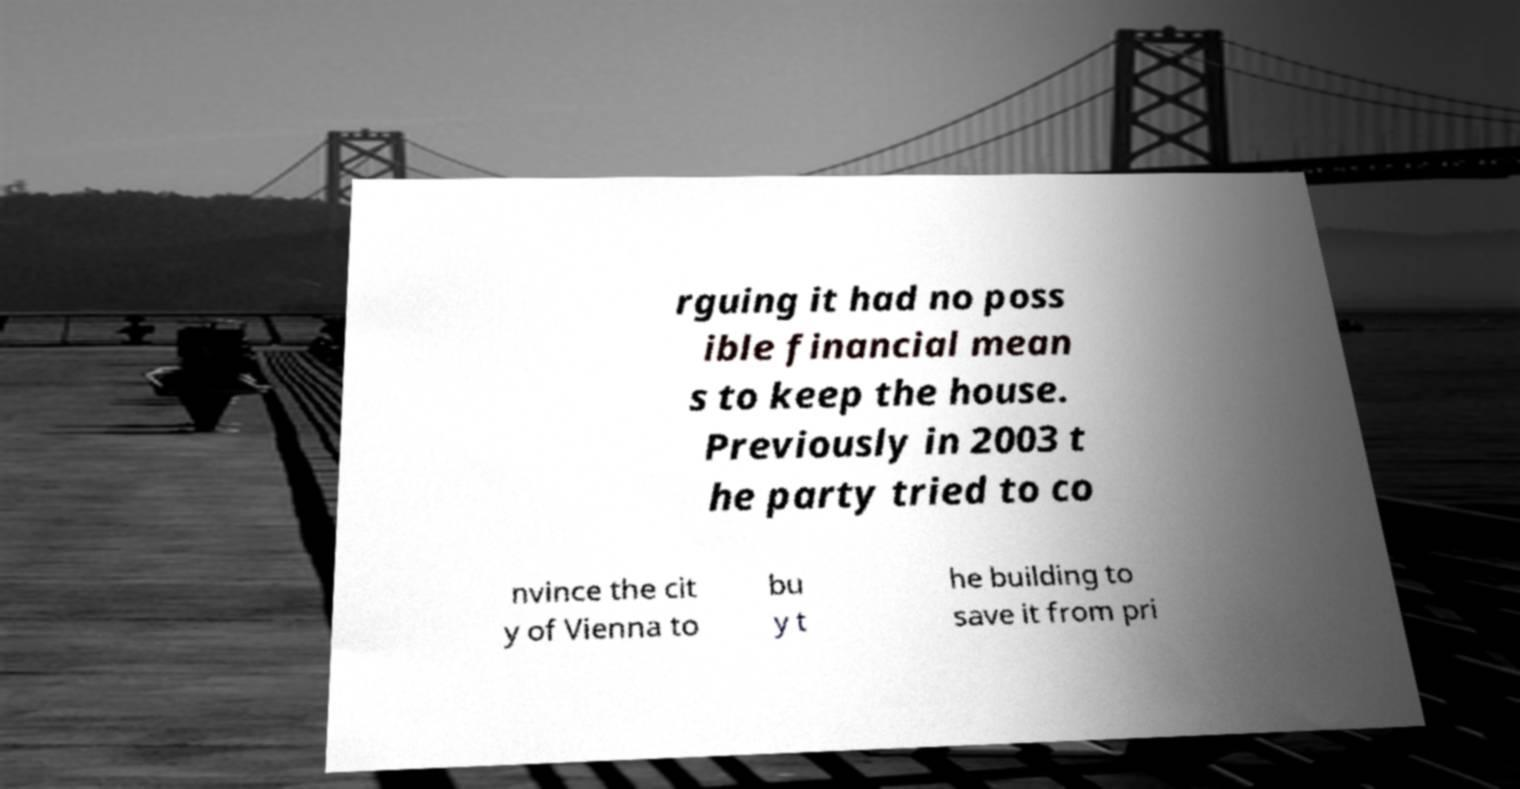Can you read and provide the text displayed in the image?This photo seems to have some interesting text. Can you extract and type it out for me? rguing it had no poss ible financial mean s to keep the house. Previously in 2003 t he party tried to co nvince the cit y of Vienna to bu y t he building to save it from pri 